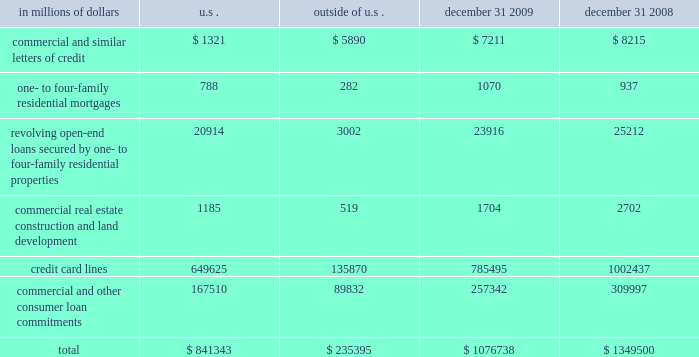Credit commitments and lines of credit the table below summarizes citigroup 2019s credit commitments as of december 31 , 2009 and december 31 , 2008 : in millions of dollars u.s .
Outside of december 31 , december 31 .
The majority of unused commitments are contingent upon customers 2019 maintaining specific credit standards .
Commercial commitments generally have floating interest rates and fixed expiration dates and may require payment of fees .
Such fees ( net of certain direct costs ) are deferred and , upon exercise of the commitment , amortized over the life of the loan or , if exercise is deemed remote , amortized over the commitment period .
Commercial and similar letters of credit a commercial letter of credit is an instrument by which citigroup substitutes its credit for that of a customer to enable the customer to finance the purchase of goods or to incur other commitments .
Citigroup issues a letter on behalf of its client to a supplier and agrees to pay the supplier upon presentation of documentary evidence that the supplier has performed in accordance with the terms of the letter of credit .
When a letter of credit is drawn , the customer is then required to reimburse citigroup .
One- to four-family residential mortgages a one- to four-family residential mortgage commitment is a written confirmation from citigroup to a seller of a property that the bank will advance the specified sums enabling the buyer to complete the purchase .
Revolving open-end loans secured by one- to four-family residential properties revolving open-end loans secured by one- to four-family residential properties are essentially home equity lines of credit .
A home equity line of credit is a loan secured by a primary residence or second home to the extent of the excess of fair market value over the debt outstanding for the first mortgage .
Commercial real estate , construction and land development commercial real estate , construction and land development include unused portions of commitments to extend credit for the purpose of financing commercial and multifamily residential properties as well as land development projects .
Both secured-by-real-estate and unsecured commitments are included in this line , as well as undistributed loan proceeds , where there is an obligation to advance for construction progress payments .
However , this line only includes those extensions of credit that , once funded , will be classified as total loans , net on the consolidated balance sheet .
Credit card lines citigroup provides credit to customers by issuing credit cards .
The credit card lines are unconditionally cancellable by the issuer .
Commercial and other consumer loan commitments commercial and other consumer loan commitments include overdraft and liquidity facilities , as well as commercial commitments to make or purchase loans , to purchase third-party receivables , to provide note issuance or revolving underwriting facilities and to invest in the form of equity .
Amounts include $ 126 billion and $ 170 billion with an original maturity of less than one year at december 31 , 2009 and december 31 , 2008 , respectively .
In addition , included in this line item are highly leveraged financing commitments , which are agreements that provide funding to a borrower with higher levels of debt ( measured by the ratio of debt capital to equity capital of the borrower ) than is generally considered normal for other companies .
This type of financing is commonly employed in corporate acquisitions , management buy-outs and similar transactions. .
What was the percent of the commercial and similar letters of credit in the u.s to outside the u.s in 2009? 
Rationale: in 2009 for every $ 22.4 of the commercial and similar letters of credit in the u.s there was $ 100 outside the u.s in 2009
Computations: (1321 / 5890)
Answer: 0.22428. 